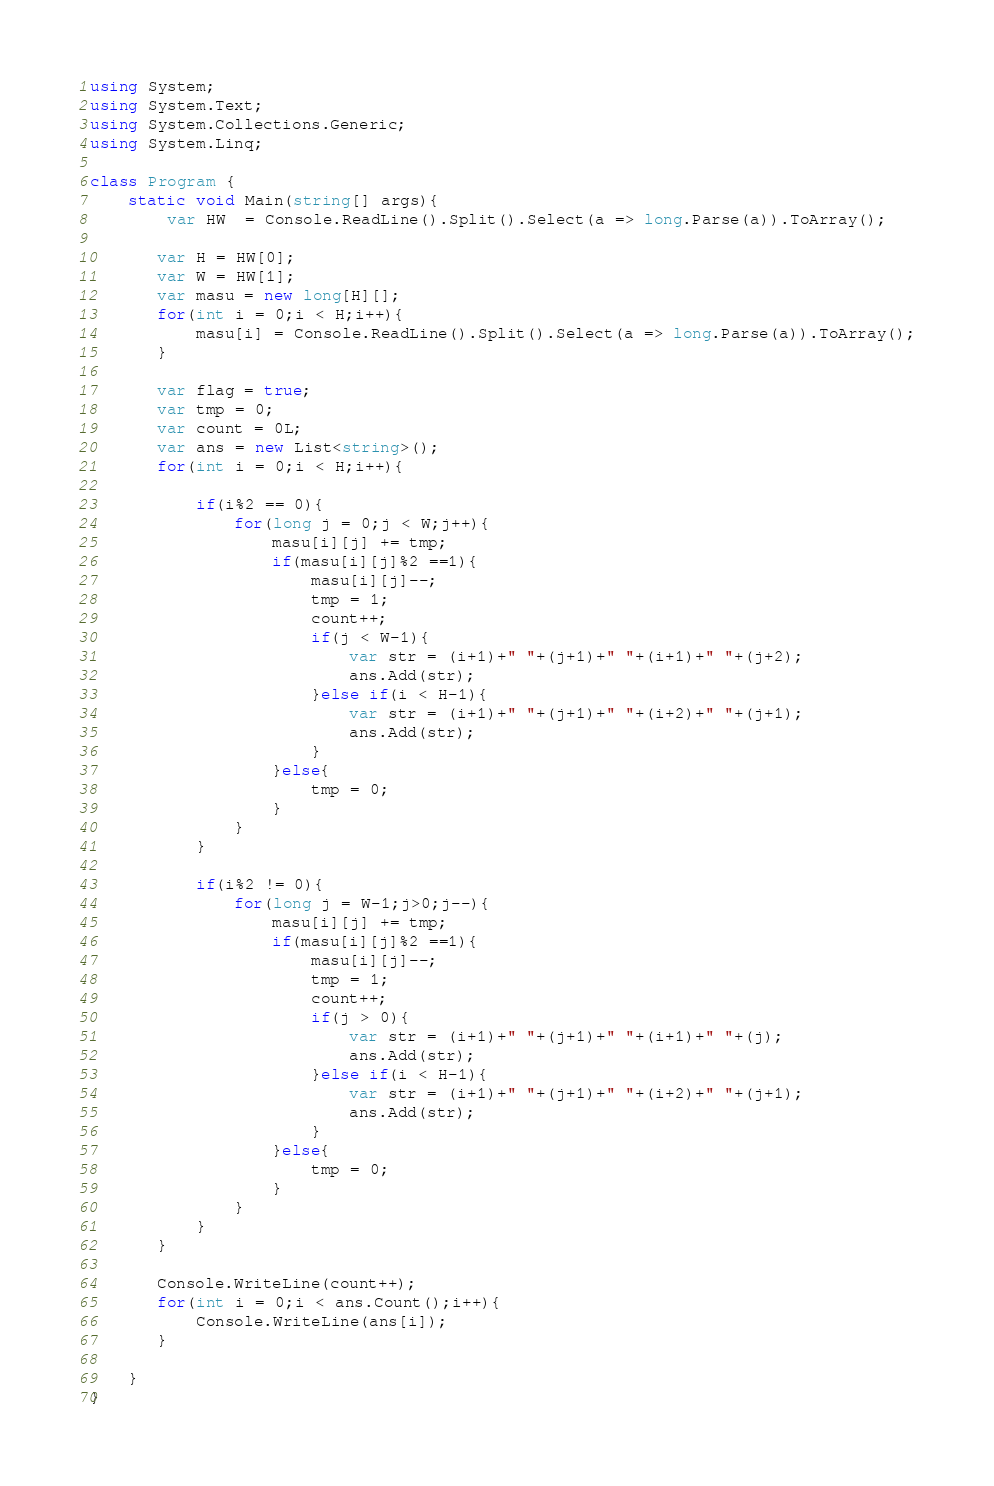<code> <loc_0><loc_0><loc_500><loc_500><_C#_>using System;
using System.Text;
using System.Collections.Generic;
using System.Linq;
 
class Program {
    static void Main(string[] args){
        var HW  = Console.ReadLine().Split().Select(a => long.Parse(a)).ToArray();
        
       var H = HW[0];
       var W = HW[1];
       var masu = new long[H][];
       for(int i = 0;i < H;i++){
           masu[i] = Console.ReadLine().Split().Select(a => long.Parse(a)).ToArray();
       }
       
       var flag = true;
       var tmp = 0;
       var count = 0L;
       var ans = new List<string>();
       for(int i = 0;i < H;i++){
           
           if(i%2 == 0){
               for(long j = 0;j < W;j++){
                   masu[i][j] += tmp;
                   if(masu[i][j]%2 ==1){
                       masu[i][j]--;
                       tmp = 1;
                       count++;
                       if(j < W-1){
                           var str = (i+1)+" "+(j+1)+" "+(i+1)+" "+(j+2);
                           ans.Add(str);
                       }else if(i < H-1){
                           var str = (i+1)+" "+(j+1)+" "+(i+2)+" "+(j+1);
                           ans.Add(str);
                       }
                   }else{
                       tmp = 0;
                   }
               }
           }
           
           if(i%2 != 0){
               for(long j = W-1;j>0;j--){
                   masu[i][j] += tmp;
                   if(masu[i][j]%2 ==1){
                       masu[i][j]--;
                       tmp = 1;
                       count++;
                       if(j > 0){
                           var str = (i+1)+" "+(j+1)+" "+(i+1)+" "+(j);
                           ans.Add(str);
                       }else if(i < H-1){
                           var str = (i+1)+" "+(j+1)+" "+(i+2)+" "+(j+1);
                           ans.Add(str);
                       }
                   }else{
                       tmp = 0;
                   }
               }
           }
       }
       
       Console.WriteLine(count++);
       for(int i = 0;i < ans.Count();i++){
           Console.WriteLine(ans[i]);
       }
       
    }      
}
</code> 